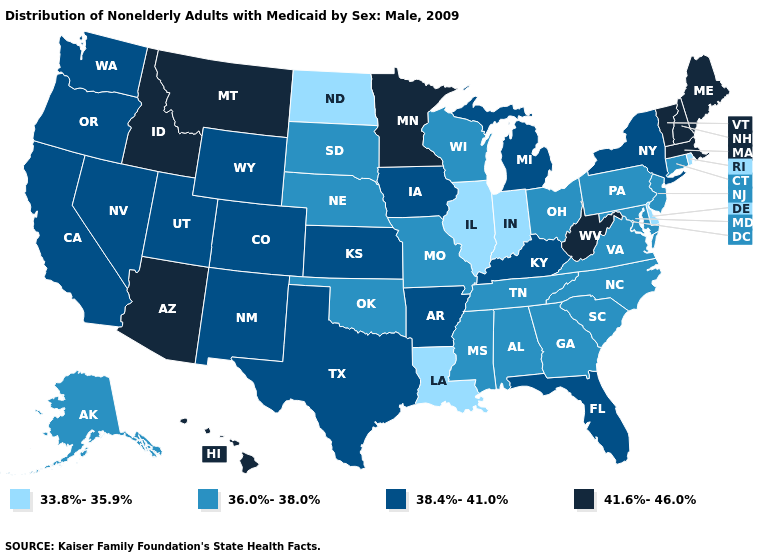Does New Jersey have the highest value in the Northeast?
Quick response, please. No. Which states have the lowest value in the USA?
Quick response, please. Delaware, Illinois, Indiana, Louisiana, North Dakota, Rhode Island. What is the value of Iowa?
Give a very brief answer. 38.4%-41.0%. What is the value of Rhode Island?
Quick response, please. 33.8%-35.9%. What is the value of Utah?
Write a very short answer. 38.4%-41.0%. Does Mississippi have the same value as South Dakota?
Be succinct. Yes. Does Hawaii have the highest value in the West?
Be succinct. Yes. Which states have the lowest value in the USA?
Answer briefly. Delaware, Illinois, Indiana, Louisiana, North Dakota, Rhode Island. Does Michigan have the highest value in the MidWest?
Short answer required. No. Name the states that have a value in the range 38.4%-41.0%?
Concise answer only. Arkansas, California, Colorado, Florida, Iowa, Kansas, Kentucky, Michigan, Nevada, New Mexico, New York, Oregon, Texas, Utah, Washington, Wyoming. Name the states that have a value in the range 38.4%-41.0%?
Quick response, please. Arkansas, California, Colorado, Florida, Iowa, Kansas, Kentucky, Michigan, Nevada, New Mexico, New York, Oregon, Texas, Utah, Washington, Wyoming. Is the legend a continuous bar?
Short answer required. No. What is the value of New Hampshire?
Quick response, please. 41.6%-46.0%. Is the legend a continuous bar?
Write a very short answer. No. Name the states that have a value in the range 33.8%-35.9%?
Concise answer only. Delaware, Illinois, Indiana, Louisiana, North Dakota, Rhode Island. 